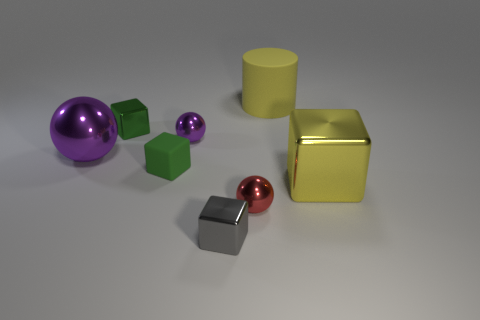Subtract 2 balls. How many balls are left? 1 Subtract all yellow blocks. How many blocks are left? 3 Subtract all yellow cubes. How many cubes are left? 3 Subtract all yellow cubes. How many green balls are left? 0 Add 2 brown matte blocks. How many objects exist? 10 Subtract 1 green cubes. How many objects are left? 7 Subtract all cylinders. How many objects are left? 7 Subtract all green spheres. Subtract all red cylinders. How many spheres are left? 3 Subtract all small matte objects. Subtract all small red metal spheres. How many objects are left? 6 Add 4 tiny green things. How many tiny green things are left? 6 